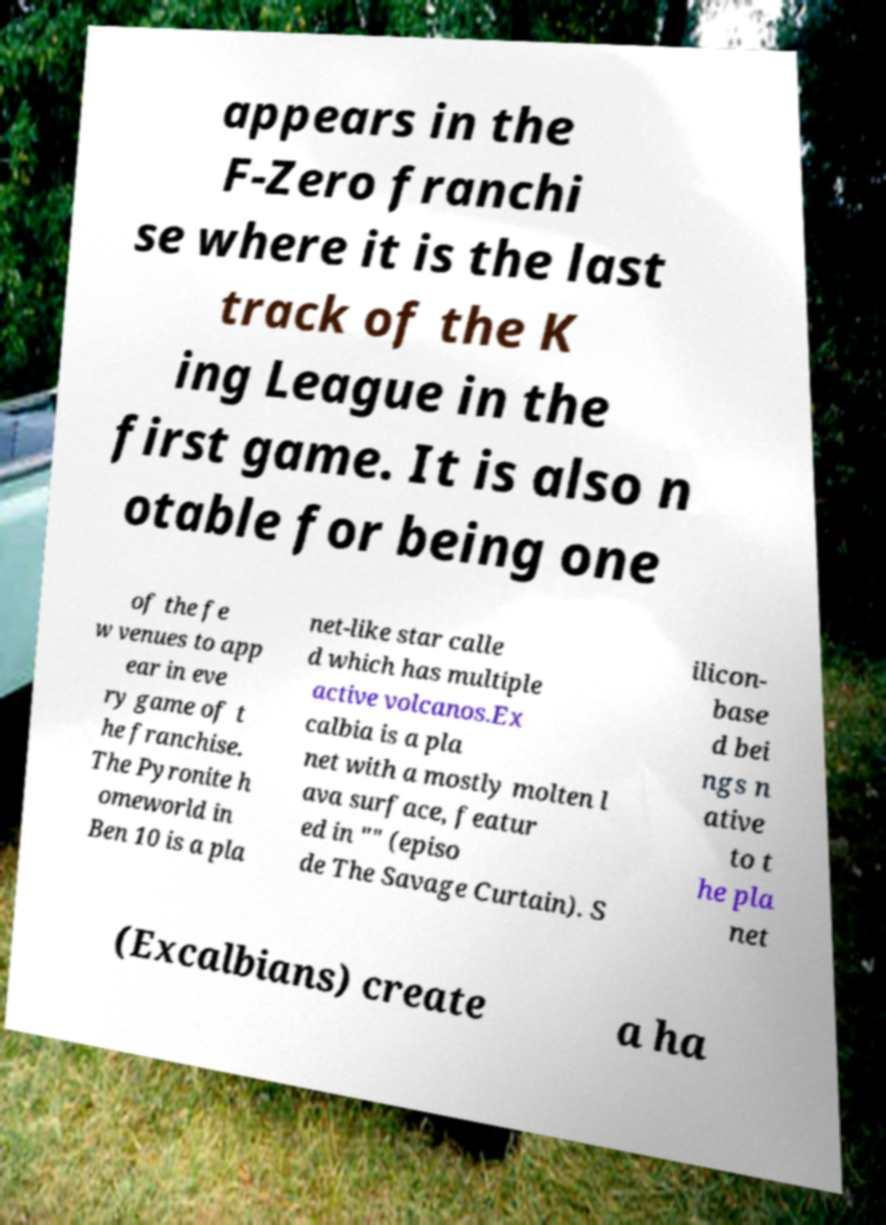Can you read and provide the text displayed in the image?This photo seems to have some interesting text. Can you extract and type it out for me? appears in the F-Zero franchi se where it is the last track of the K ing League in the first game. It is also n otable for being one of the fe w venues to app ear in eve ry game of t he franchise. The Pyronite h omeworld in Ben 10 is a pla net-like star calle d which has multiple active volcanos.Ex calbia is a pla net with a mostly molten l ava surface, featur ed in "" (episo de The Savage Curtain). S ilicon- base d bei ngs n ative to t he pla net (Excalbians) create a ha 